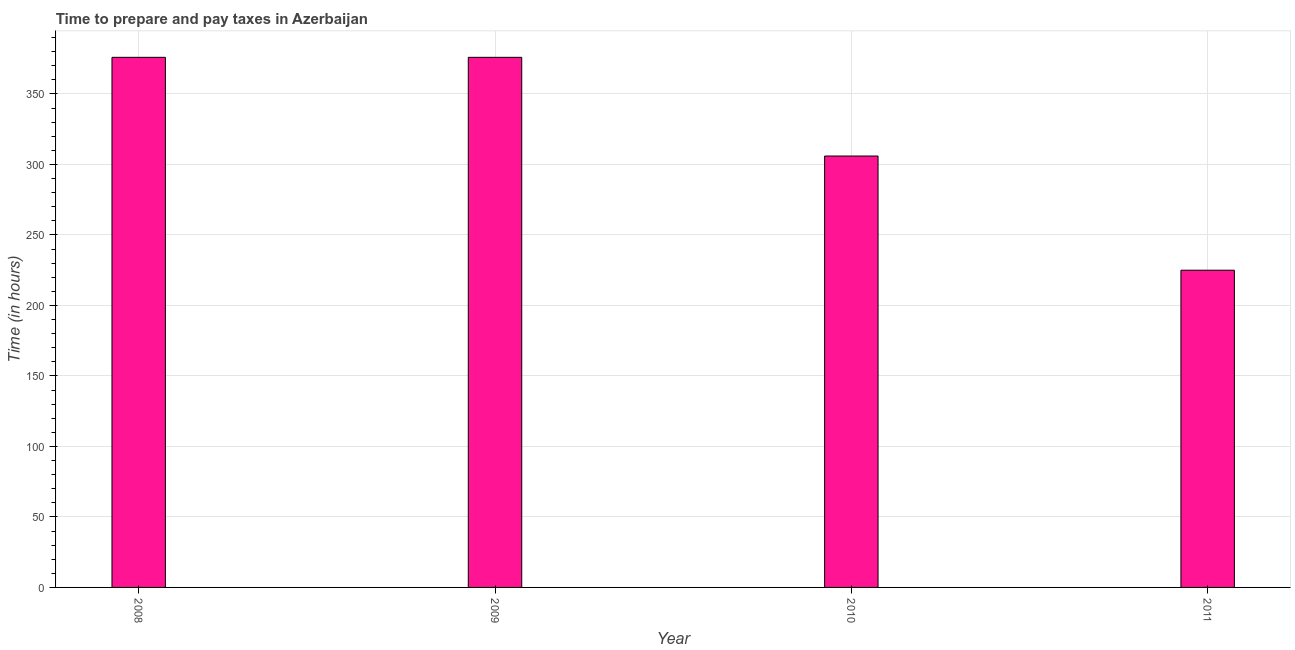Does the graph contain any zero values?
Ensure brevity in your answer.  No. What is the title of the graph?
Provide a succinct answer. Time to prepare and pay taxes in Azerbaijan. What is the label or title of the Y-axis?
Offer a terse response. Time (in hours). What is the time to prepare and pay taxes in 2009?
Your answer should be compact. 376. Across all years, what is the maximum time to prepare and pay taxes?
Your answer should be compact. 376. Across all years, what is the minimum time to prepare and pay taxes?
Provide a short and direct response. 225. In which year was the time to prepare and pay taxes maximum?
Make the answer very short. 2008. In which year was the time to prepare and pay taxes minimum?
Provide a succinct answer. 2011. What is the sum of the time to prepare and pay taxes?
Ensure brevity in your answer.  1283. What is the difference between the time to prepare and pay taxes in 2008 and 2009?
Give a very brief answer. 0. What is the average time to prepare and pay taxes per year?
Make the answer very short. 320. What is the median time to prepare and pay taxes?
Make the answer very short. 341. In how many years, is the time to prepare and pay taxes greater than 290 hours?
Your response must be concise. 3. Do a majority of the years between 2008 and 2010 (inclusive) have time to prepare and pay taxes greater than 360 hours?
Make the answer very short. Yes. What is the ratio of the time to prepare and pay taxes in 2008 to that in 2011?
Provide a short and direct response. 1.67. Is the difference between the time to prepare and pay taxes in 2010 and 2011 greater than the difference between any two years?
Make the answer very short. No. What is the difference between the highest and the lowest time to prepare and pay taxes?
Your answer should be very brief. 151. How many bars are there?
Offer a terse response. 4. Are all the bars in the graph horizontal?
Offer a terse response. No. What is the difference between two consecutive major ticks on the Y-axis?
Your response must be concise. 50. Are the values on the major ticks of Y-axis written in scientific E-notation?
Offer a terse response. No. What is the Time (in hours) of 2008?
Provide a short and direct response. 376. What is the Time (in hours) of 2009?
Offer a terse response. 376. What is the Time (in hours) in 2010?
Ensure brevity in your answer.  306. What is the Time (in hours) of 2011?
Your response must be concise. 225. What is the difference between the Time (in hours) in 2008 and 2011?
Keep it short and to the point. 151. What is the difference between the Time (in hours) in 2009 and 2011?
Your response must be concise. 151. What is the ratio of the Time (in hours) in 2008 to that in 2010?
Offer a terse response. 1.23. What is the ratio of the Time (in hours) in 2008 to that in 2011?
Give a very brief answer. 1.67. What is the ratio of the Time (in hours) in 2009 to that in 2010?
Make the answer very short. 1.23. What is the ratio of the Time (in hours) in 2009 to that in 2011?
Give a very brief answer. 1.67. What is the ratio of the Time (in hours) in 2010 to that in 2011?
Your answer should be compact. 1.36. 